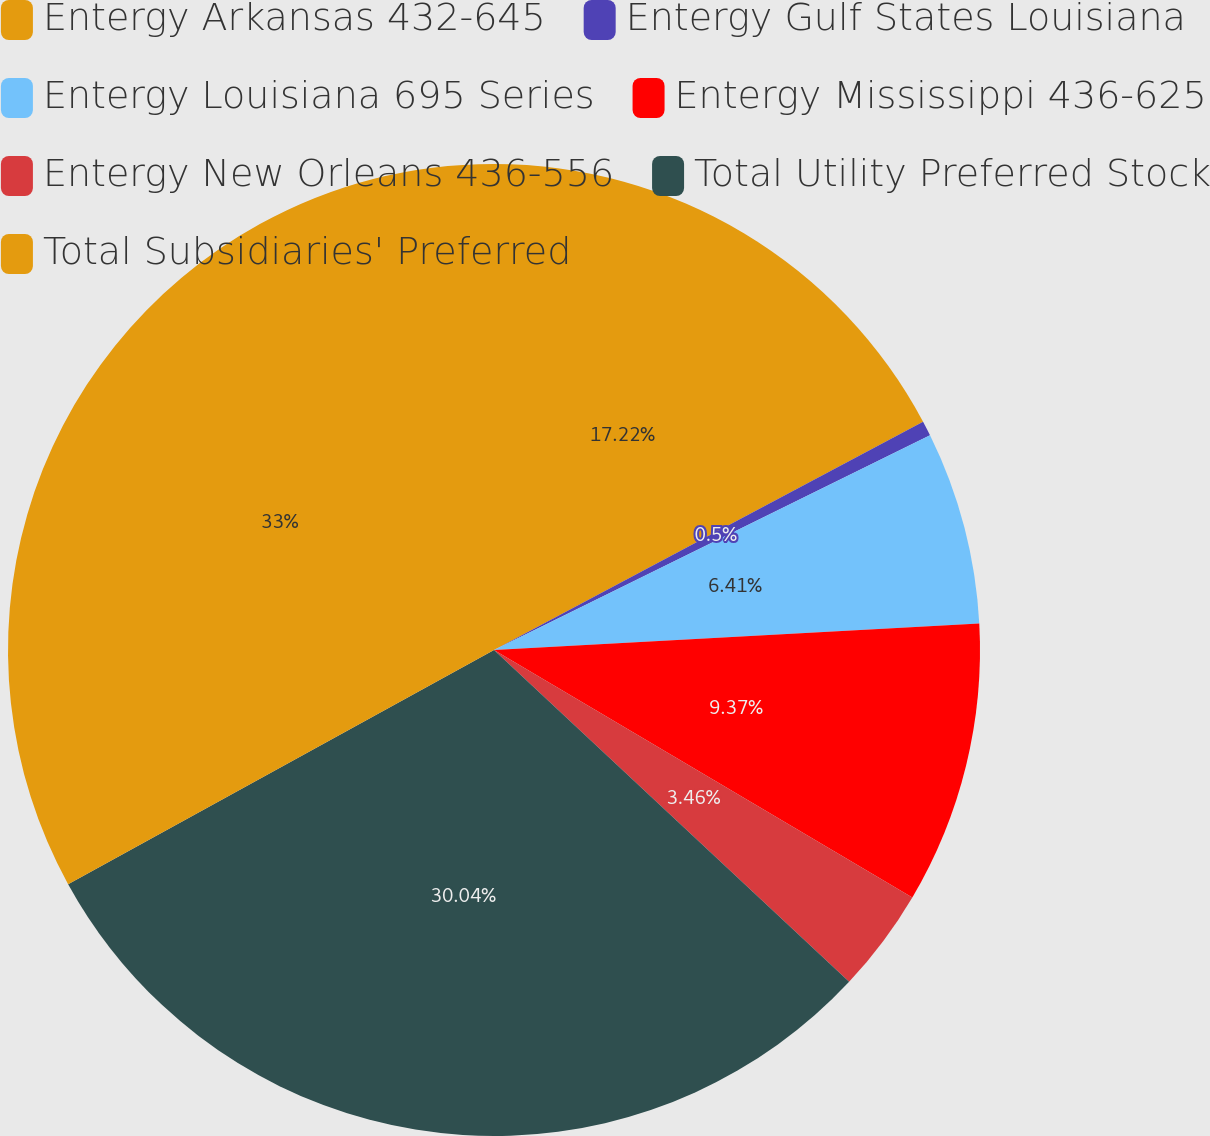<chart> <loc_0><loc_0><loc_500><loc_500><pie_chart><fcel>Entergy Arkansas 432-645<fcel>Entergy Gulf States Louisiana<fcel>Entergy Louisiana 695 Series<fcel>Entergy Mississippi 436-625<fcel>Entergy New Orleans 436-556<fcel>Total Utility Preferred Stock<fcel>Total Subsidiaries' Preferred<nl><fcel>17.22%<fcel>0.5%<fcel>6.41%<fcel>9.37%<fcel>3.46%<fcel>30.04%<fcel>33.0%<nl></chart> 